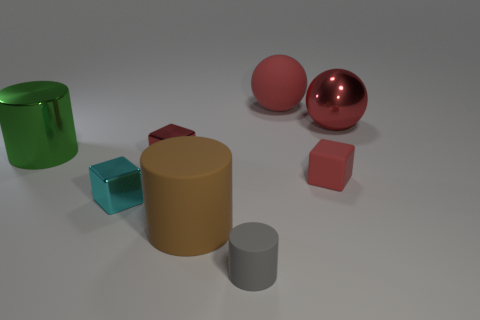What can you infer about the lighting source in this image? The lighting in the image appears to be diffused overhead lighting, given the soft shadows cast directly beneath the objects. The reflection on the metallic surfaces suggests there is a significant source of light above and possibly to the right, as noted by the bright spots of light reflected on the sphere and large cylinder. The lack of harsh shadows or intense contrasts indicates the light source isn't very close to the objects. Does the lighting affect the colors of the objects? Absolutely, the lighting has an impact on how we perceive the colors of the objects. The diffused nature of the light softens the intensity of the colors. For instance, the metallic objects have highlights that could otherwise not be seen under different lighting conditions, and the matte objects appear to have uniform coloration without strong highlights or reflected colors. 